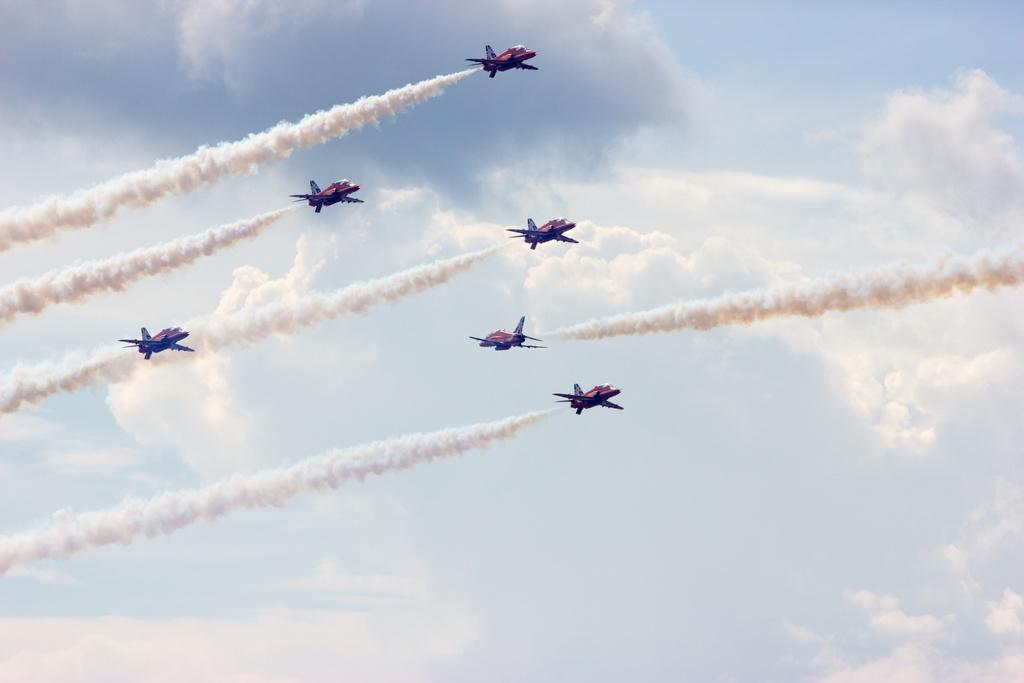How many jet planes are in the image? There are six jet planes in the image. What are the jet planes doing in the image? The jet planes are flying in the air. What can be seen coming out of the jet planes? There is smoke visible in the image. What is visible at the top of the image? The sky is visible at the top of the image. What is the value of the moon in the image? There is no moon present in the image, so it is not possible to determine its value. 